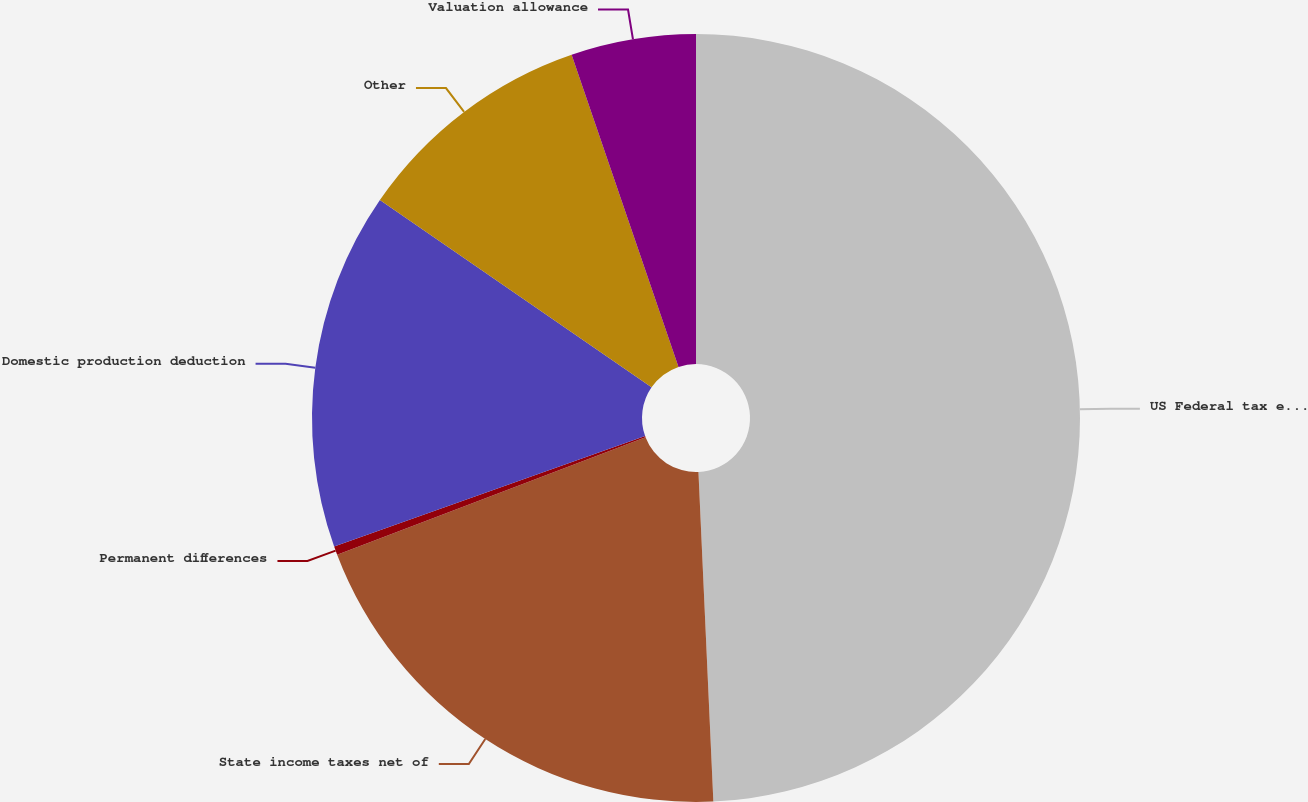<chart> <loc_0><loc_0><loc_500><loc_500><pie_chart><fcel>US Federal tax expense at<fcel>State income taxes net of<fcel>Permanent differences<fcel>Domestic production deduction<fcel>Other<fcel>Valuation allowance<nl><fcel>49.28%<fcel>19.93%<fcel>0.36%<fcel>15.04%<fcel>10.14%<fcel>5.25%<nl></chart> 